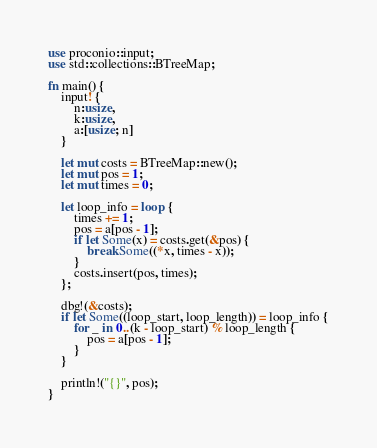<code> <loc_0><loc_0><loc_500><loc_500><_Rust_>use proconio::input;
use std::collections::BTreeMap;

fn main() {
    input! {
        n:usize,
        k:usize,
        a:[usize; n]
    }

    let mut costs = BTreeMap::new();
    let mut pos = 1;
    let mut times = 0;

    let loop_info = loop {
        times += 1;
        pos = a[pos - 1];
        if let Some(x) = costs.get(&pos) {
            break Some((*x, times - x));
        }
        costs.insert(pos, times);
    };

    dbg!(&costs);
    if let Some((loop_start, loop_length)) = loop_info {
        for _ in 0..(k - loop_start) % loop_length {
            pos = a[pos - 1];
        }
    }

    println!("{}", pos);
}
</code> 